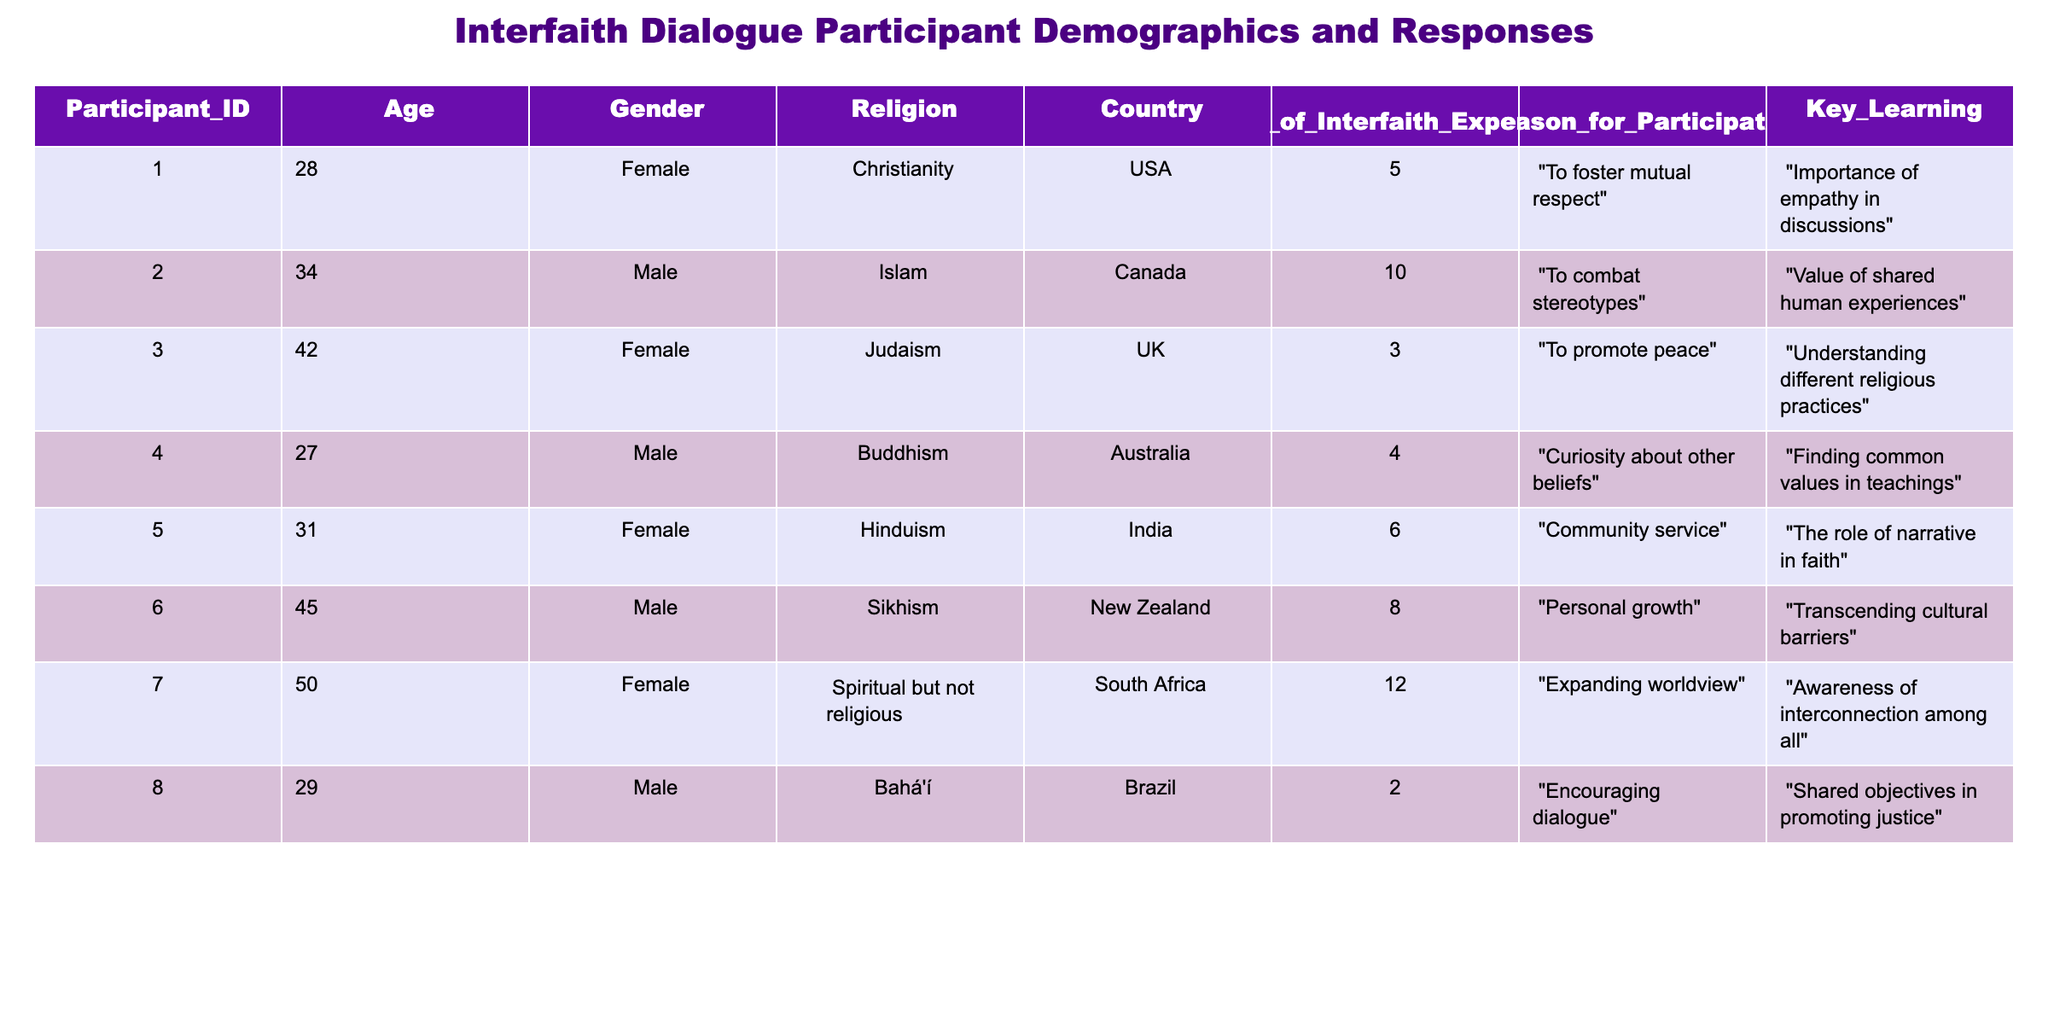What is the age of the oldest participant? The oldest participant is identified by comparing the ages listed for each individual. Scanning through the ages, the values are 28, 34, 42, 27, 31, 45, 50, and 29. The maximum age is 50.
Answer: 50 How many participants are male? By counting the instances in the Gender column, we find four males listed: participant IDs 2, 4, 6, and 8. Therefore, the count of male participants is 4.
Answer: 4 What percentage of participants are from the USA? To calculate this percentage, we first find the number of participants from the USA, which is 1 out of 8 total participants. The calculation is (1/8) * 100 = 12.5%.
Answer: 12.5% What is the average number of years of interfaith experience among all participants? To find the average, we sum the years of interfaith experience for all participants: 5 + 10 + 3 + 4 + 6 + 8 + 12 + 2 = 50. There are 8 participants, so we divide the total years by the number of participants: 50 / 8 = 6.25 years.
Answer: 6.25 Is there any participant whose reason for participation involved personal growth? Looking through the Reasons for Participation section in the table, participant ID 6 specified "Personal growth" as a reason. Thus, the answer is yes.
Answer: Yes What is the most common key learning among the participants? The key learnings from participants are varied. However, the learning of "Importance of empathy in discussions" and "Value of shared human experiences" both emphasize understanding. Although no single learning stands out as the most common, "importance of empathy" is the most explicitly stated.
Answer: Importance of empathy in discussions How many participants identified their religion as a form of spirituality other than organized religion? In the Religion column, we see that participant ID 7 is categorized under "Spiritual but not religious." Therefore, there is 1 participant in this category.
Answer: 1 Which country has the participant with the least interfaith experience? By reviewing the Years of Interfaith Experience column, we find that participant ID 8 has 2 years of experience while all others have more. Therefore, participant ID 8 from Brazil has the least experience.
Answer: Brazil 